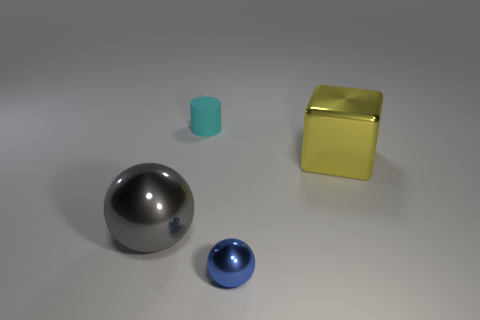Is there a cyan object behind the big metal object to the left of the large thing behind the large gray shiny sphere?
Provide a short and direct response. Yes. What material is the sphere on the left side of the metallic sphere that is in front of the large gray metallic thing?
Your response must be concise. Metal. What is the object that is in front of the cyan object and behind the gray metal sphere made of?
Provide a succinct answer. Metal. Are there any other big gray things of the same shape as the big gray metal thing?
Your answer should be very brief. No. Is there a shiny cube to the left of the object that is right of the small metallic object?
Make the answer very short. No. What number of blue spheres have the same material as the large yellow object?
Give a very brief answer. 1. Are any large purple rubber spheres visible?
Make the answer very short. No. Are the cylinder and the thing that is to the right of the blue ball made of the same material?
Keep it short and to the point. No. Is the number of things that are on the right side of the tiny shiny object greater than the number of tiny blue cubes?
Give a very brief answer. Yes. Are there an equal number of blue metallic objects that are right of the blue metallic object and small blue objects that are in front of the small cyan cylinder?
Give a very brief answer. No. 